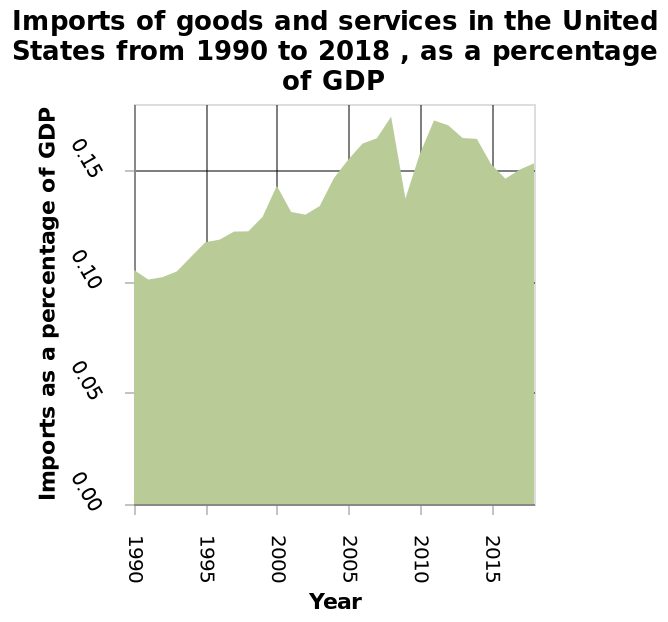<image>
What does the x-axis represent in the line chart? The x-axis represents the year. please summary the statistics and relations of the chart There is steady growth of imports as a percentage of GDP from 1990 to 2015. Although a clear dip is shown circa 2008 but recovers swiftly to predicted levels by 2010. How long did it take for the percentage of imports as a percentage of GDP to recover after the dip in 2008? The percentage of imports as a percentage of GDP recovered swiftly to predicted levels by 2010. What does the y-axis measure? The y-axis measures Imports as a percentage of GDP. 